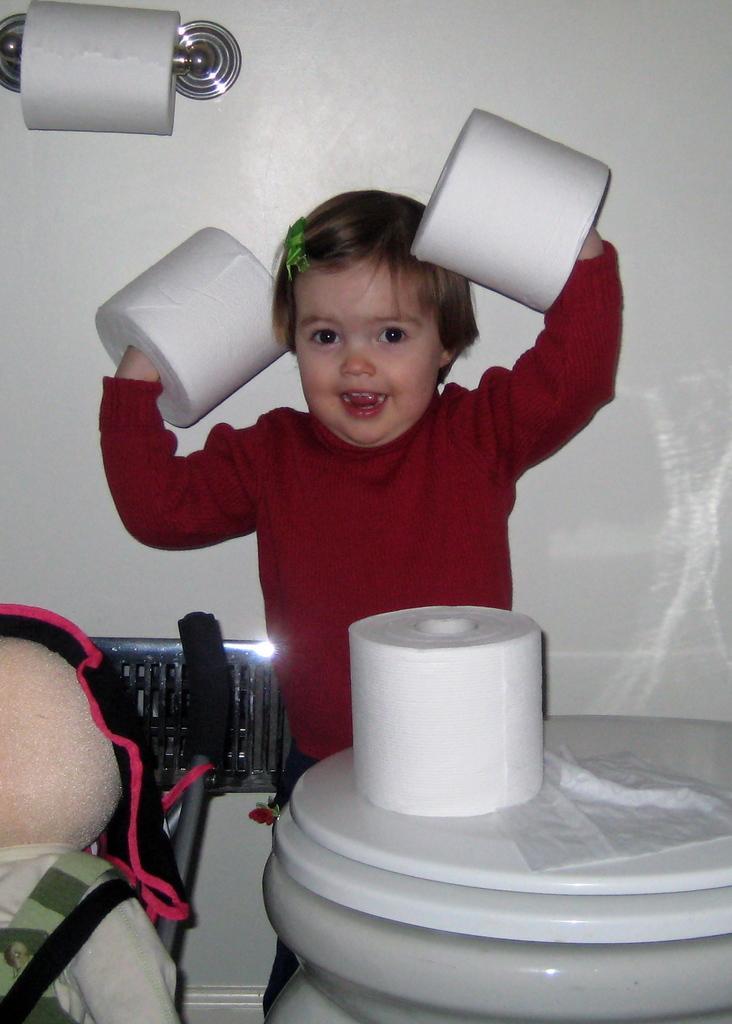Please provide a concise description of this image. In this image we can see a child holding tissue rolls. There is a stand. On that there is a tissue roll. In the back there is a wall with tissue roll and holder. In the left bottom corner we can see a doll. 